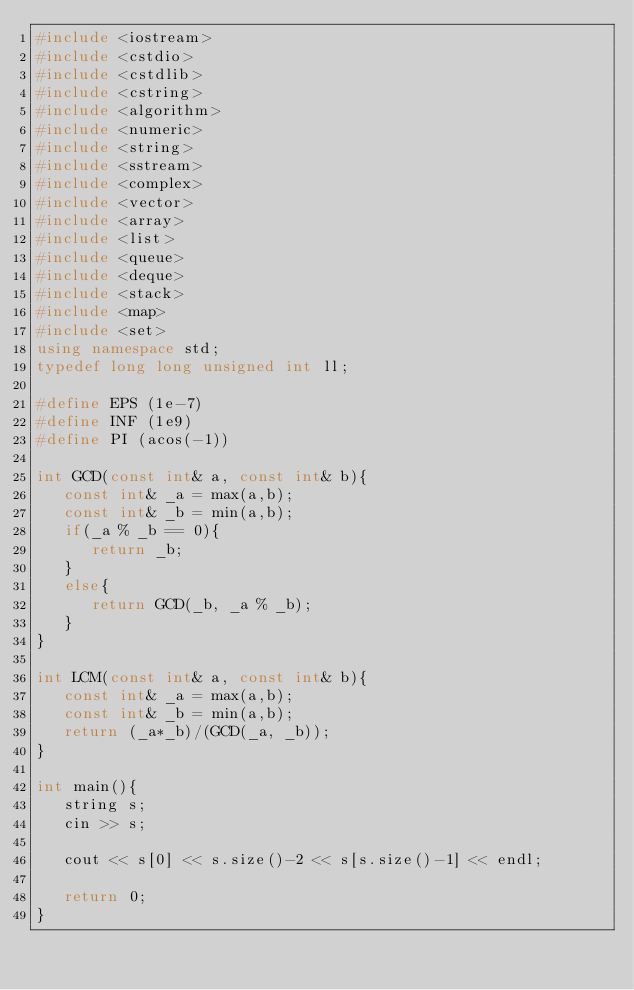Convert code to text. <code><loc_0><loc_0><loc_500><loc_500><_C++_>#include <iostream>
#include <cstdio>
#include <cstdlib>
#include <cstring>
#include <algorithm>
#include <numeric>
#include <string>
#include <sstream>
#include <complex>
#include <vector>
#include <array>
#include <list>
#include <queue>
#include <deque>
#include <stack>
#include <map>
#include <set>
using namespace std;
typedef long long unsigned int ll;

#define EPS (1e-7)
#define INF (1e9)
#define PI (acos(-1))

int GCD(const int& a, const int& b){
   const int& _a = max(a,b);
   const int& _b = min(a,b);
   if(_a % _b == 0){
      return _b;
   }
   else{
      return GCD(_b, _a % _b);
   }
}

int LCM(const int& a, const int& b){
   const int& _a = max(a,b);
   const int& _b = min(a,b);
   return (_a*_b)/(GCD(_a, _b));
}

int main(){
   string s;
   cin >> s;

   cout << s[0] << s.size()-2 << s[s.size()-1] << endl;

   return 0;
}</code> 